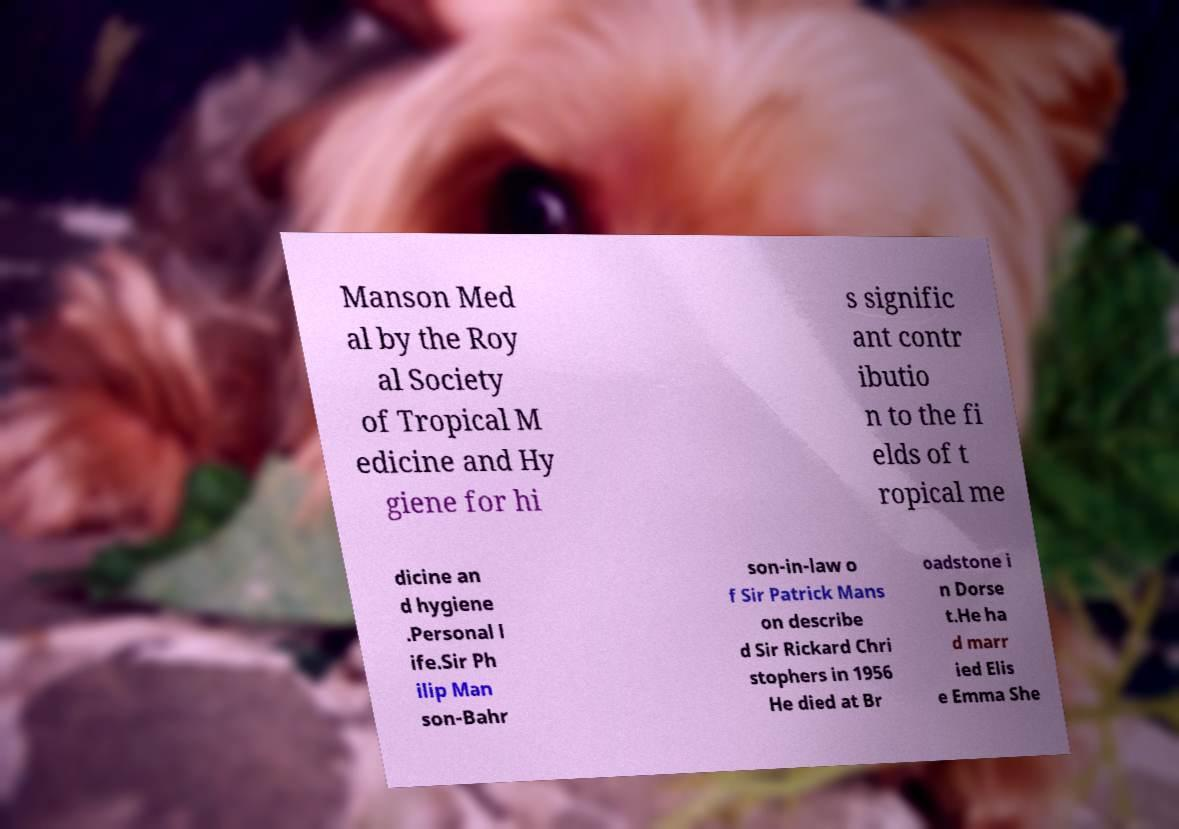Please read and relay the text visible in this image. What does it say? Manson Med al by the Roy al Society of Tropical M edicine and Hy giene for hi s signific ant contr ibutio n to the fi elds of t ropical me dicine an d hygiene .Personal l ife.Sir Ph ilip Man son-Bahr son-in-law o f Sir Patrick Mans on describe d Sir Rickard Chri stophers in 1956 He died at Br oadstone i n Dorse t.He ha d marr ied Elis e Emma She 